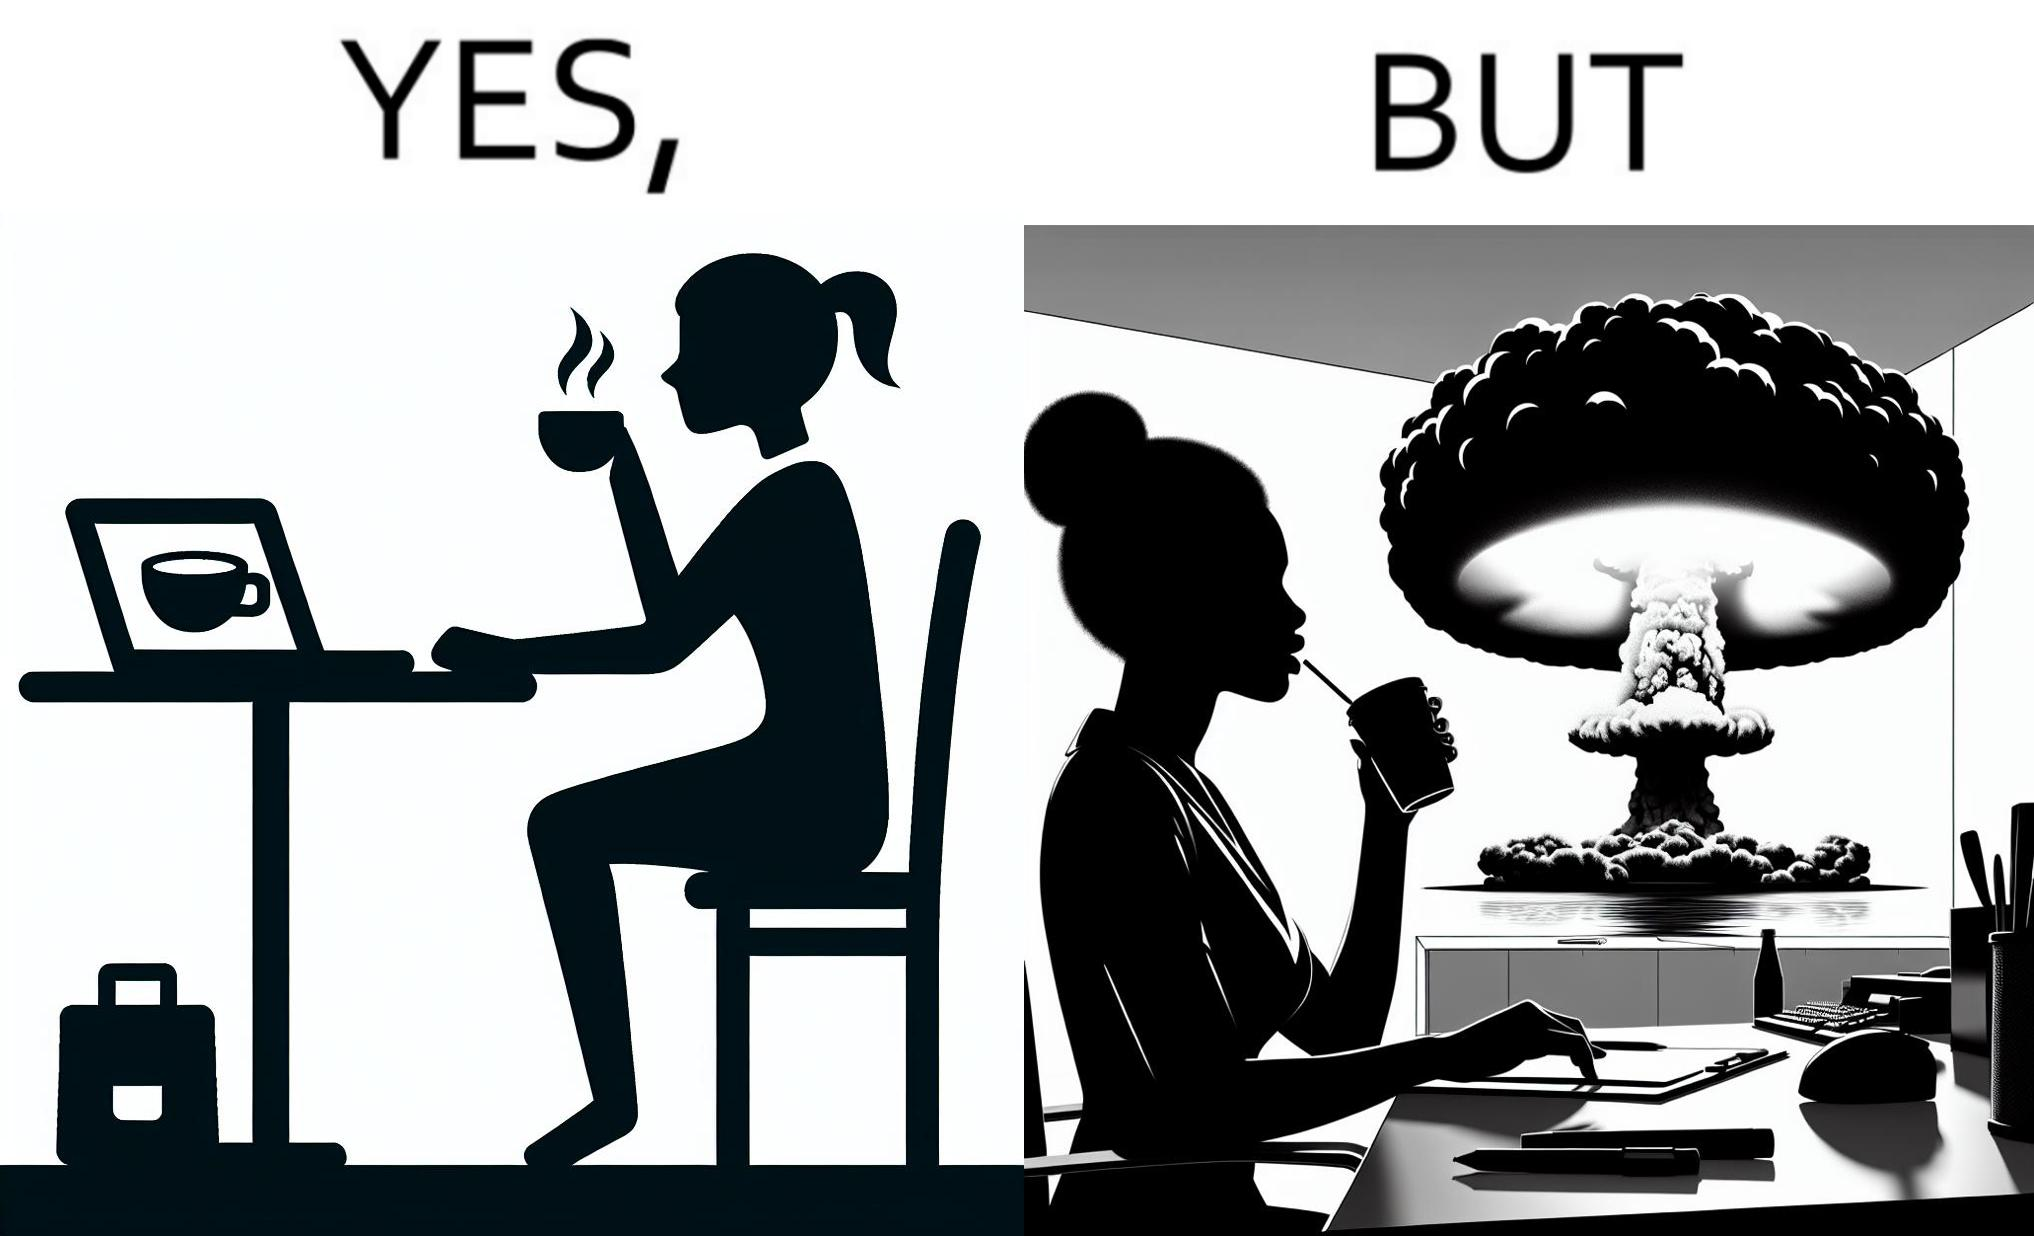Would you classify this image as satirical? Yes, this image is satirical. 